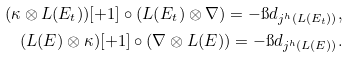<formula> <loc_0><loc_0><loc_500><loc_500>( \kappa \otimes L ( E _ { t } ) ) [ + 1 ] \circ ( L ( E _ { t } ) \otimes \nabla ) = - \i d _ { j ^ { h } ( L ( E _ { t } ) ) } , \\ ( L ( E ) \otimes \kappa ) [ + 1 ] \circ ( \nabla \otimes L ( E ) ) = - \i d _ { j ^ { h } ( L ( E ) ) } .</formula> 